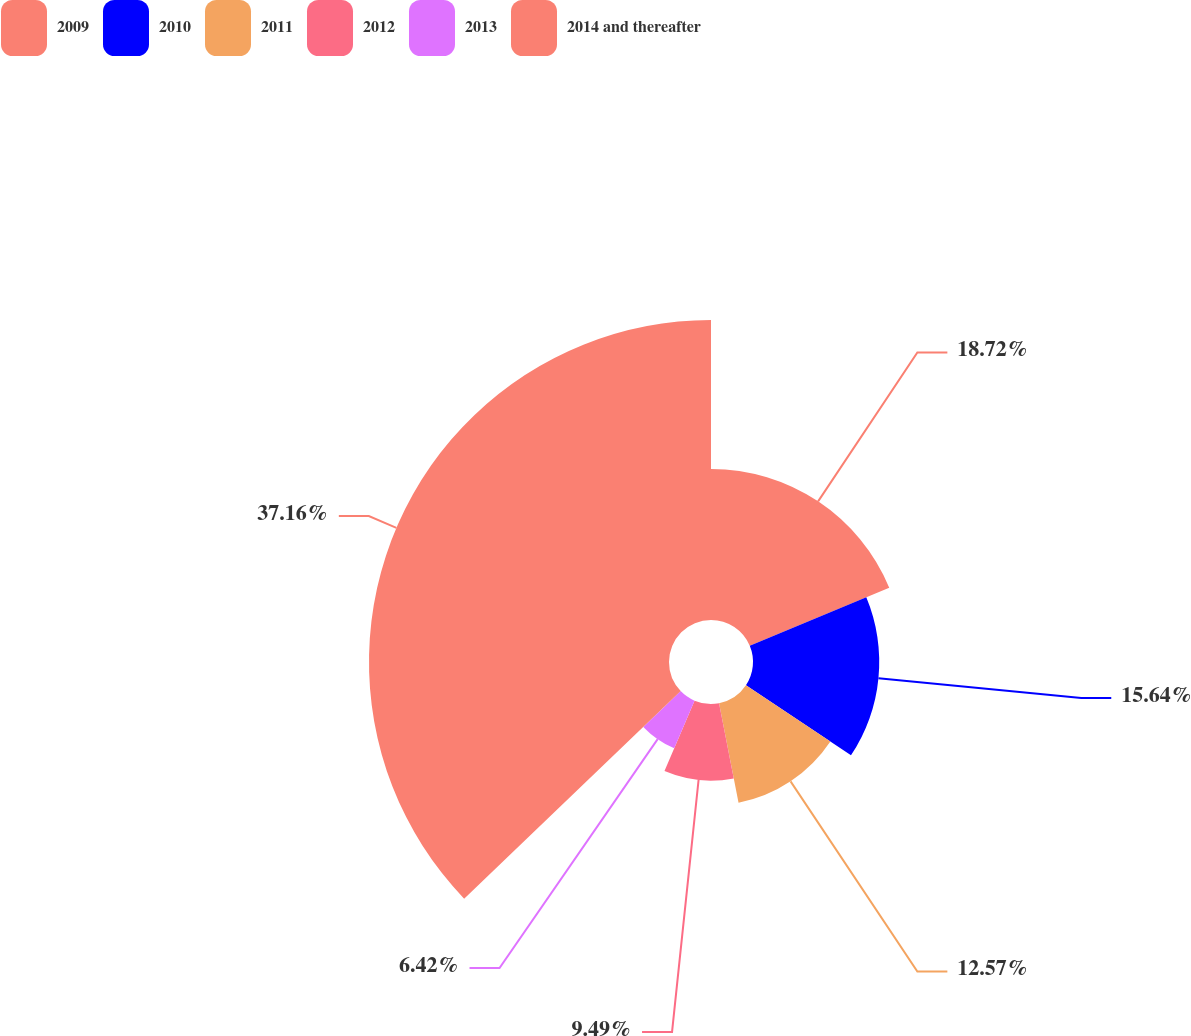<chart> <loc_0><loc_0><loc_500><loc_500><pie_chart><fcel>2009<fcel>2010<fcel>2011<fcel>2012<fcel>2013<fcel>2014 and thereafter<nl><fcel>18.72%<fcel>15.64%<fcel>12.57%<fcel>9.49%<fcel>6.42%<fcel>37.17%<nl></chart> 